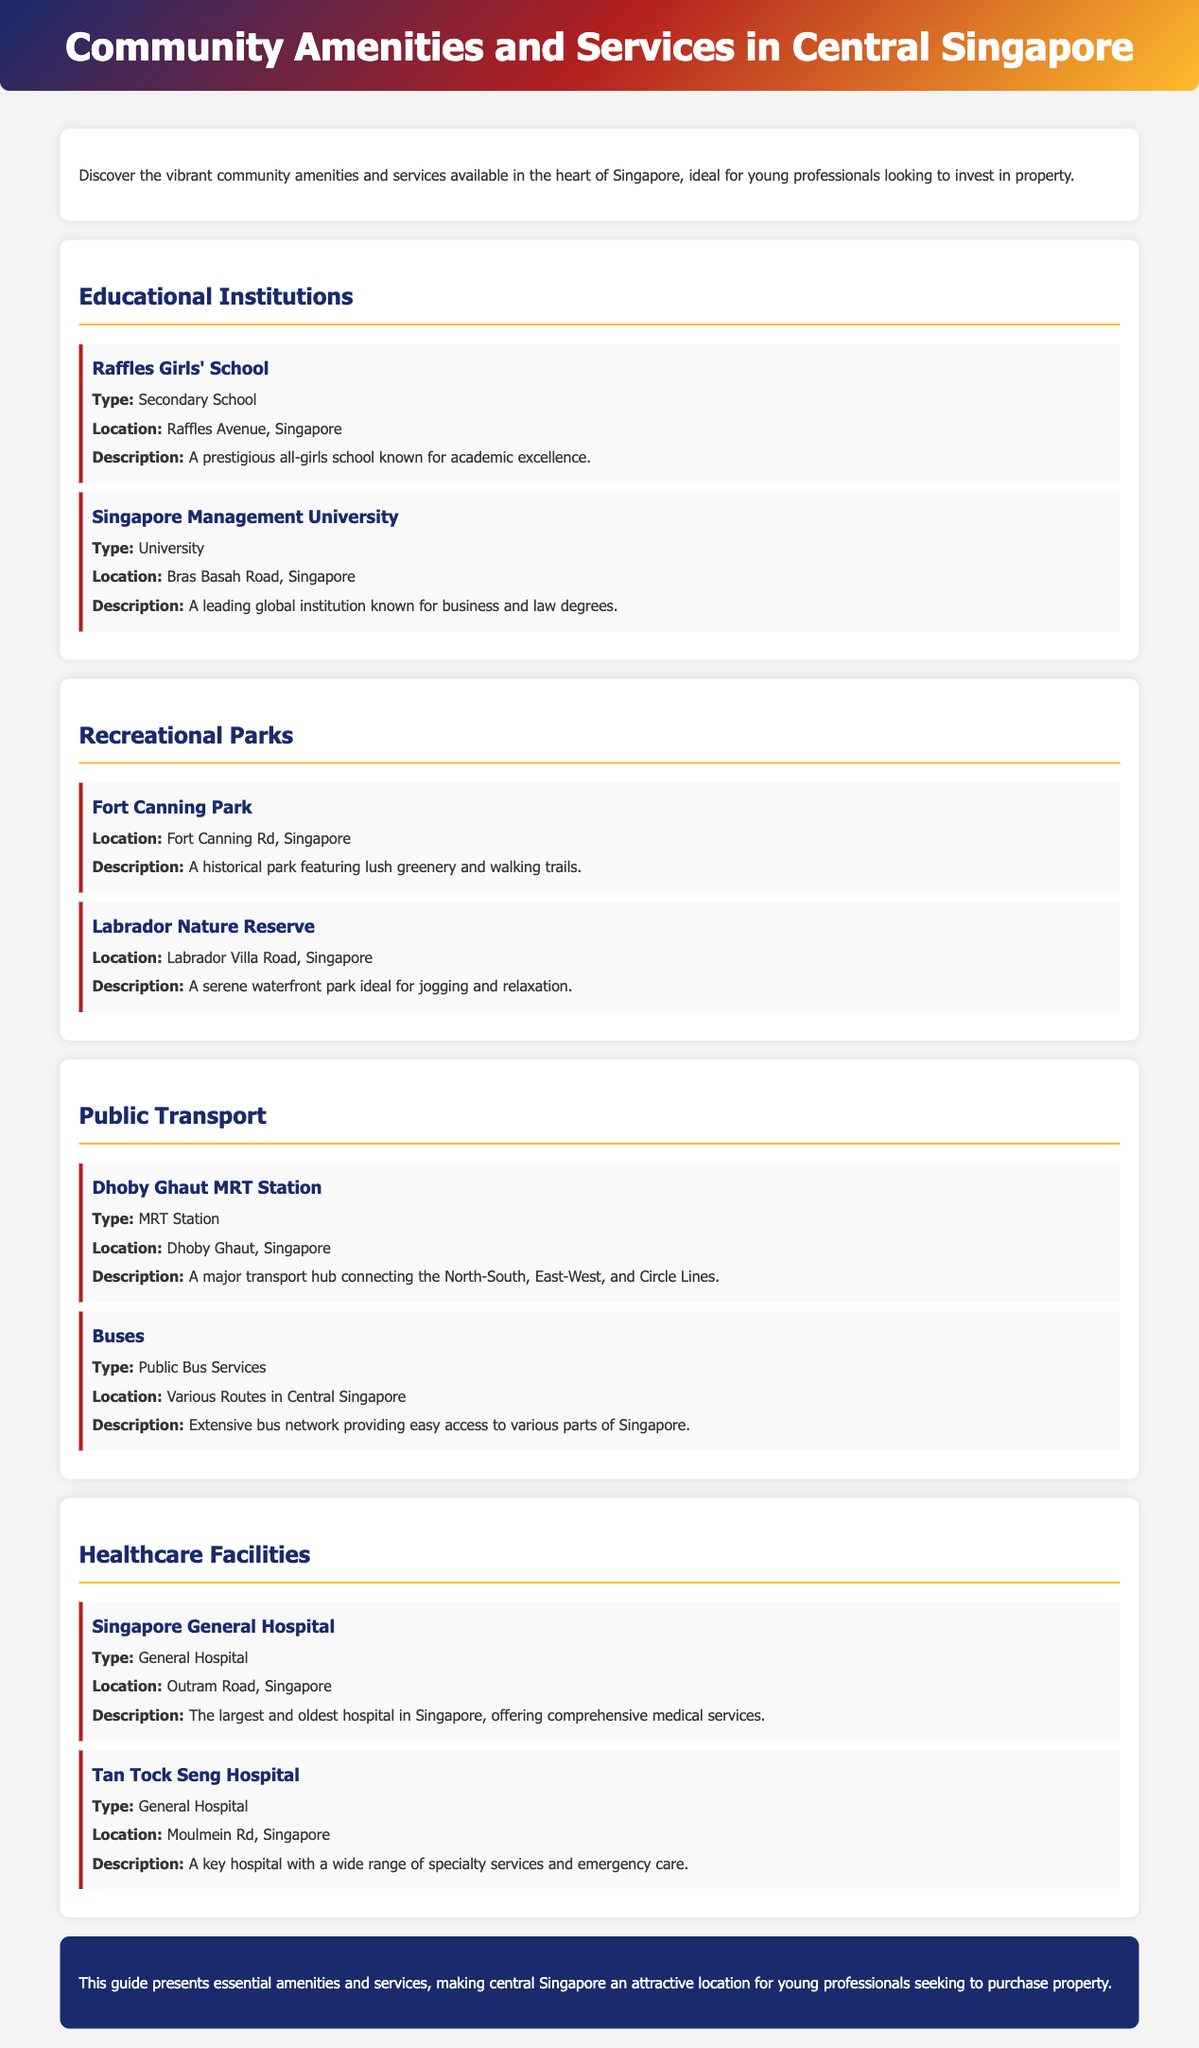What is the name of a secondary school mentioned? Raffles Girls' School is listed as a secondary school in the document.
Answer: Raffles Girls' School Where is Singapore Management University located? The document states that Singapore Management University is located on Bras Basah Road.
Answer: Bras Basah Road What type of park is Fort Canning Park? Fort Canning Park is described as a historical park featuring lush greenery and walking trails.
Answer: Historical park How many MRT stations are mentioned? The document mentions one MRT station, which is Dhoby Ghaut MRT Station.
Answer: One Which hospital is the largest in Singapore? The document identifies Singapore General Hospital as the largest and oldest hospital in Singapore.
Answer: Singapore General Hospital What type of public transportation service is extensively available? The document mentions public bus services as an extensive transport option in central Singapore.
Answer: Bus services What is a key feature of Labrador Nature Reserve? Labrador Nature Reserve is characterized as a serene waterfront park ideal for jogging and relaxation.
Answer: Serene waterfront park Which educational institution is known for business and law degrees? Singapore Management University is recognized for its business and law degrees.
Answer: Singapore Management University What type of facility is Tan Tock Seng Hospital? The document categorizes Tan Tock Seng Hospital as a general hospital.
Answer: General Hospital 